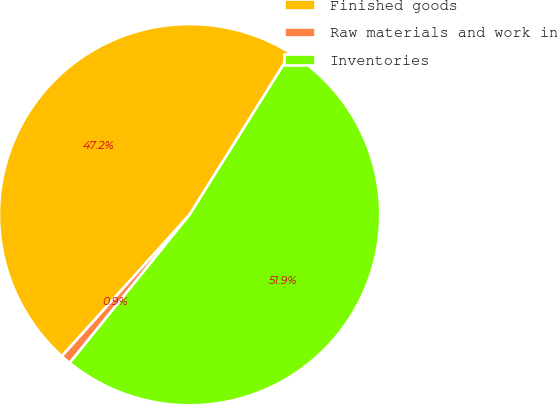<chart> <loc_0><loc_0><loc_500><loc_500><pie_chart><fcel>Finished goods<fcel>Raw materials and work in<fcel>Inventories<nl><fcel>47.21%<fcel>0.86%<fcel>51.93%<nl></chart> 